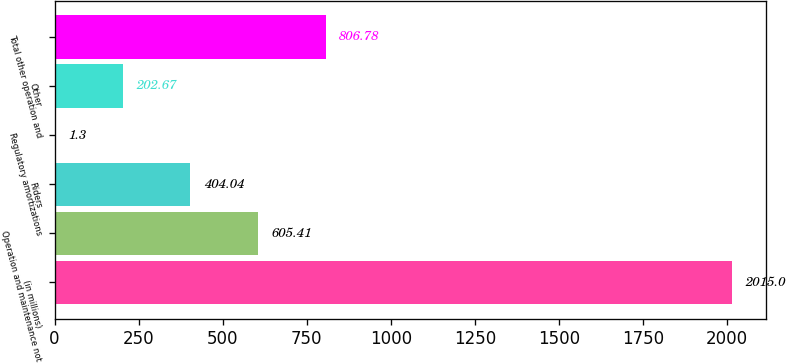Convert chart. <chart><loc_0><loc_0><loc_500><loc_500><bar_chart><fcel>(in millions)<fcel>Operation and maintenance not<fcel>Riders<fcel>Regulatory amortizations<fcel>Other<fcel>Total other operation and<nl><fcel>2015<fcel>605.41<fcel>404.04<fcel>1.3<fcel>202.67<fcel>806.78<nl></chart> 